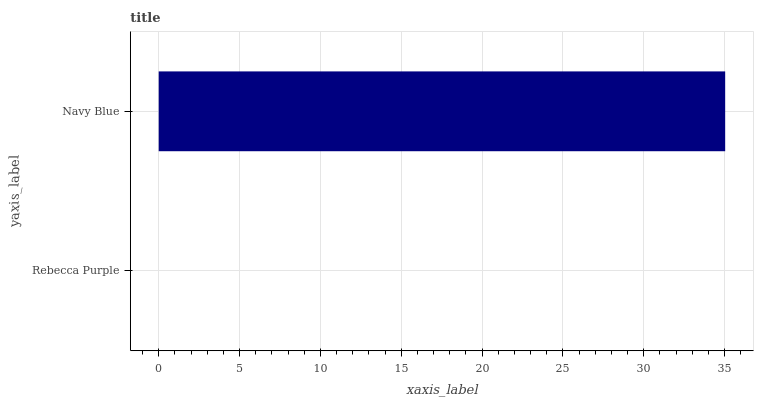Is Rebecca Purple the minimum?
Answer yes or no. Yes. Is Navy Blue the maximum?
Answer yes or no. Yes. Is Navy Blue the minimum?
Answer yes or no. No. Is Navy Blue greater than Rebecca Purple?
Answer yes or no. Yes. Is Rebecca Purple less than Navy Blue?
Answer yes or no. Yes. Is Rebecca Purple greater than Navy Blue?
Answer yes or no. No. Is Navy Blue less than Rebecca Purple?
Answer yes or no. No. Is Navy Blue the high median?
Answer yes or no. Yes. Is Rebecca Purple the low median?
Answer yes or no. Yes. Is Rebecca Purple the high median?
Answer yes or no. No. Is Navy Blue the low median?
Answer yes or no. No. 